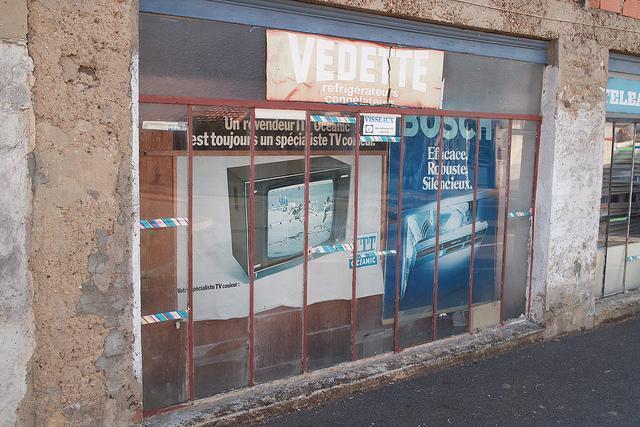How many of these giraffe are taller than the wires?
Give a very brief answer. 0. 